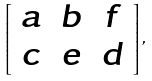<formula> <loc_0><loc_0><loc_500><loc_500>\left [ \begin{array} { c c c } a & b & f \\ c & e & d \end{array} \right ] ,</formula> 